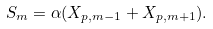<formula> <loc_0><loc_0><loc_500><loc_500>S _ { m } = \alpha ( X _ { p , m - 1 } + X _ { p , m + 1 } ) .</formula> 